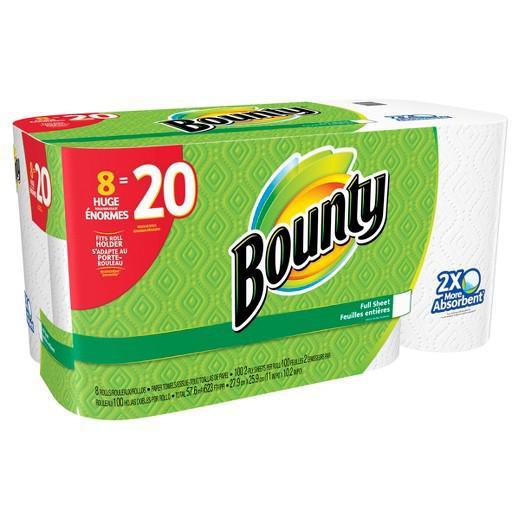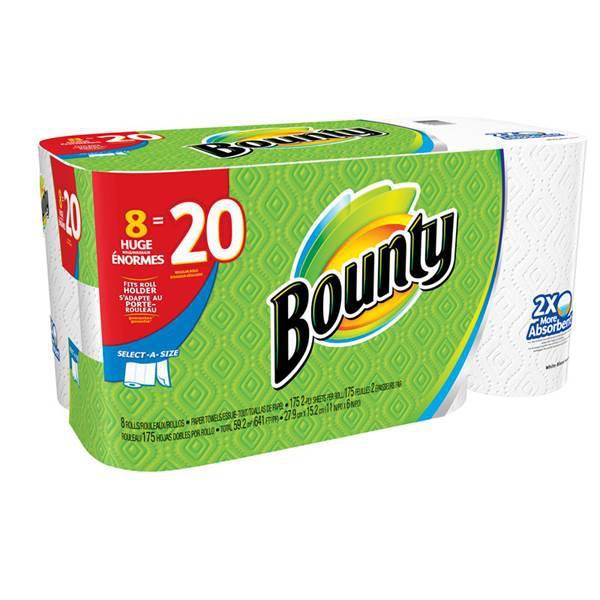The first image is the image on the left, the second image is the image on the right. Assess this claim about the two images: "There are 1 or more packages of paper towels facing right.". Correct or not? Answer yes or no. Yes. 